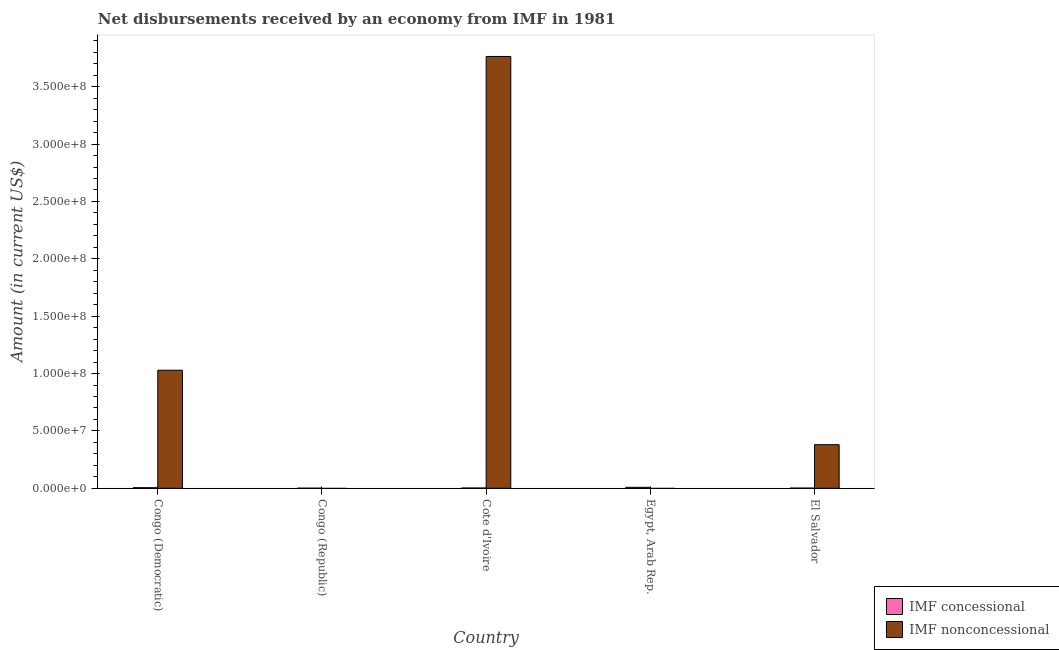Are the number of bars on each tick of the X-axis equal?
Your answer should be compact. No. How many bars are there on the 4th tick from the right?
Provide a short and direct response. 1. What is the label of the 3rd group of bars from the left?
Provide a succinct answer. Cote d'Ivoire. What is the net concessional disbursements from imf in El Salvador?
Keep it short and to the point. 1.56e+05. Across all countries, what is the maximum net non concessional disbursements from imf?
Give a very brief answer. 3.76e+08. Across all countries, what is the minimum net concessional disbursements from imf?
Your answer should be compact. 5.80e+04. In which country was the net concessional disbursements from imf maximum?
Give a very brief answer. Egypt, Arab Rep. What is the total net non concessional disbursements from imf in the graph?
Offer a very short reply. 5.17e+08. What is the difference between the net concessional disbursements from imf in Congo (Democratic) and that in Cote d'Ivoire?
Your answer should be compact. 2.73e+05. What is the difference between the net non concessional disbursements from imf in Congo (Republic) and the net concessional disbursements from imf in Egypt, Arab Rep.?
Keep it short and to the point. -8.38e+05. What is the average net non concessional disbursements from imf per country?
Offer a very short reply. 1.03e+08. What is the difference between the net non concessional disbursements from imf and net concessional disbursements from imf in Cote d'Ivoire?
Make the answer very short. 3.76e+08. In how many countries, is the net non concessional disbursements from imf greater than 360000000 US$?
Give a very brief answer. 1. What is the ratio of the net non concessional disbursements from imf in Congo (Democratic) to that in Cote d'Ivoire?
Give a very brief answer. 0.27. Is the net concessional disbursements from imf in Congo (Republic) less than that in El Salvador?
Provide a succinct answer. Yes. Is the difference between the net non concessional disbursements from imf in Congo (Democratic) and Cote d'Ivoire greater than the difference between the net concessional disbursements from imf in Congo (Democratic) and Cote d'Ivoire?
Your answer should be compact. No. What is the difference between the highest and the second highest net non concessional disbursements from imf?
Provide a short and direct response. 2.73e+08. What is the difference between the highest and the lowest net non concessional disbursements from imf?
Provide a succinct answer. 3.76e+08. Is the sum of the net concessional disbursements from imf in Cote d'Ivoire and Egypt, Arab Rep. greater than the maximum net non concessional disbursements from imf across all countries?
Your response must be concise. No. How are the legend labels stacked?
Give a very brief answer. Vertical. What is the title of the graph?
Provide a succinct answer. Net disbursements received by an economy from IMF in 1981. What is the Amount (in current US$) in IMF concessional in Congo (Democratic)?
Offer a very short reply. 5.04e+05. What is the Amount (in current US$) of IMF nonconcessional in Congo (Democratic)?
Provide a short and direct response. 1.03e+08. What is the Amount (in current US$) in IMF concessional in Congo (Republic)?
Your answer should be compact. 5.80e+04. What is the Amount (in current US$) of IMF nonconcessional in Congo (Republic)?
Provide a short and direct response. 0. What is the Amount (in current US$) in IMF concessional in Cote d'Ivoire?
Make the answer very short. 2.31e+05. What is the Amount (in current US$) in IMF nonconcessional in Cote d'Ivoire?
Your response must be concise. 3.76e+08. What is the Amount (in current US$) in IMF concessional in Egypt, Arab Rep.?
Offer a very short reply. 8.38e+05. What is the Amount (in current US$) in IMF concessional in El Salvador?
Give a very brief answer. 1.56e+05. What is the Amount (in current US$) of IMF nonconcessional in El Salvador?
Your response must be concise. 3.80e+07. Across all countries, what is the maximum Amount (in current US$) in IMF concessional?
Give a very brief answer. 8.38e+05. Across all countries, what is the maximum Amount (in current US$) of IMF nonconcessional?
Provide a succinct answer. 3.76e+08. Across all countries, what is the minimum Amount (in current US$) of IMF concessional?
Your response must be concise. 5.80e+04. Across all countries, what is the minimum Amount (in current US$) in IMF nonconcessional?
Your answer should be compact. 0. What is the total Amount (in current US$) of IMF concessional in the graph?
Provide a succinct answer. 1.79e+06. What is the total Amount (in current US$) of IMF nonconcessional in the graph?
Keep it short and to the point. 5.17e+08. What is the difference between the Amount (in current US$) of IMF concessional in Congo (Democratic) and that in Congo (Republic)?
Your answer should be very brief. 4.46e+05. What is the difference between the Amount (in current US$) of IMF concessional in Congo (Democratic) and that in Cote d'Ivoire?
Give a very brief answer. 2.73e+05. What is the difference between the Amount (in current US$) in IMF nonconcessional in Congo (Democratic) and that in Cote d'Ivoire?
Your response must be concise. -2.73e+08. What is the difference between the Amount (in current US$) of IMF concessional in Congo (Democratic) and that in Egypt, Arab Rep.?
Ensure brevity in your answer.  -3.34e+05. What is the difference between the Amount (in current US$) in IMF concessional in Congo (Democratic) and that in El Salvador?
Provide a short and direct response. 3.48e+05. What is the difference between the Amount (in current US$) in IMF nonconcessional in Congo (Democratic) and that in El Salvador?
Keep it short and to the point. 6.49e+07. What is the difference between the Amount (in current US$) in IMF concessional in Congo (Republic) and that in Cote d'Ivoire?
Give a very brief answer. -1.73e+05. What is the difference between the Amount (in current US$) in IMF concessional in Congo (Republic) and that in Egypt, Arab Rep.?
Your answer should be compact. -7.80e+05. What is the difference between the Amount (in current US$) of IMF concessional in Congo (Republic) and that in El Salvador?
Your response must be concise. -9.80e+04. What is the difference between the Amount (in current US$) of IMF concessional in Cote d'Ivoire and that in Egypt, Arab Rep.?
Give a very brief answer. -6.07e+05. What is the difference between the Amount (in current US$) of IMF concessional in Cote d'Ivoire and that in El Salvador?
Give a very brief answer. 7.50e+04. What is the difference between the Amount (in current US$) of IMF nonconcessional in Cote d'Ivoire and that in El Salvador?
Ensure brevity in your answer.  3.38e+08. What is the difference between the Amount (in current US$) of IMF concessional in Egypt, Arab Rep. and that in El Salvador?
Ensure brevity in your answer.  6.82e+05. What is the difference between the Amount (in current US$) in IMF concessional in Congo (Democratic) and the Amount (in current US$) in IMF nonconcessional in Cote d'Ivoire?
Your answer should be compact. -3.76e+08. What is the difference between the Amount (in current US$) of IMF concessional in Congo (Democratic) and the Amount (in current US$) of IMF nonconcessional in El Salvador?
Offer a terse response. -3.75e+07. What is the difference between the Amount (in current US$) of IMF concessional in Congo (Republic) and the Amount (in current US$) of IMF nonconcessional in Cote d'Ivoire?
Give a very brief answer. -3.76e+08. What is the difference between the Amount (in current US$) in IMF concessional in Congo (Republic) and the Amount (in current US$) in IMF nonconcessional in El Salvador?
Make the answer very short. -3.79e+07. What is the difference between the Amount (in current US$) of IMF concessional in Cote d'Ivoire and the Amount (in current US$) of IMF nonconcessional in El Salvador?
Provide a short and direct response. -3.78e+07. What is the difference between the Amount (in current US$) in IMF concessional in Egypt, Arab Rep. and the Amount (in current US$) in IMF nonconcessional in El Salvador?
Provide a succinct answer. -3.72e+07. What is the average Amount (in current US$) in IMF concessional per country?
Your answer should be compact. 3.57e+05. What is the average Amount (in current US$) in IMF nonconcessional per country?
Make the answer very short. 1.03e+08. What is the difference between the Amount (in current US$) of IMF concessional and Amount (in current US$) of IMF nonconcessional in Congo (Democratic)?
Your response must be concise. -1.02e+08. What is the difference between the Amount (in current US$) in IMF concessional and Amount (in current US$) in IMF nonconcessional in Cote d'Ivoire?
Offer a very short reply. -3.76e+08. What is the difference between the Amount (in current US$) in IMF concessional and Amount (in current US$) in IMF nonconcessional in El Salvador?
Keep it short and to the point. -3.78e+07. What is the ratio of the Amount (in current US$) of IMF concessional in Congo (Democratic) to that in Congo (Republic)?
Keep it short and to the point. 8.69. What is the ratio of the Amount (in current US$) in IMF concessional in Congo (Democratic) to that in Cote d'Ivoire?
Provide a succinct answer. 2.18. What is the ratio of the Amount (in current US$) of IMF nonconcessional in Congo (Democratic) to that in Cote d'Ivoire?
Offer a terse response. 0.27. What is the ratio of the Amount (in current US$) of IMF concessional in Congo (Democratic) to that in Egypt, Arab Rep.?
Give a very brief answer. 0.6. What is the ratio of the Amount (in current US$) of IMF concessional in Congo (Democratic) to that in El Salvador?
Give a very brief answer. 3.23. What is the ratio of the Amount (in current US$) of IMF nonconcessional in Congo (Democratic) to that in El Salvador?
Keep it short and to the point. 2.71. What is the ratio of the Amount (in current US$) of IMF concessional in Congo (Republic) to that in Cote d'Ivoire?
Provide a succinct answer. 0.25. What is the ratio of the Amount (in current US$) of IMF concessional in Congo (Republic) to that in Egypt, Arab Rep.?
Offer a very short reply. 0.07. What is the ratio of the Amount (in current US$) of IMF concessional in Congo (Republic) to that in El Salvador?
Make the answer very short. 0.37. What is the ratio of the Amount (in current US$) of IMF concessional in Cote d'Ivoire to that in Egypt, Arab Rep.?
Provide a short and direct response. 0.28. What is the ratio of the Amount (in current US$) of IMF concessional in Cote d'Ivoire to that in El Salvador?
Offer a terse response. 1.48. What is the ratio of the Amount (in current US$) of IMF nonconcessional in Cote d'Ivoire to that in El Salvador?
Offer a very short reply. 9.9. What is the ratio of the Amount (in current US$) of IMF concessional in Egypt, Arab Rep. to that in El Salvador?
Provide a succinct answer. 5.37. What is the difference between the highest and the second highest Amount (in current US$) of IMF concessional?
Make the answer very short. 3.34e+05. What is the difference between the highest and the second highest Amount (in current US$) in IMF nonconcessional?
Offer a terse response. 2.73e+08. What is the difference between the highest and the lowest Amount (in current US$) in IMF concessional?
Offer a very short reply. 7.80e+05. What is the difference between the highest and the lowest Amount (in current US$) of IMF nonconcessional?
Your answer should be very brief. 3.76e+08. 